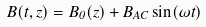Convert formula to latex. <formula><loc_0><loc_0><loc_500><loc_500>B ( t , z ) = B _ { 0 } ( z ) + B _ { A C } \sin ( \omega t )</formula> 